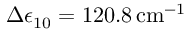Convert formula to latex. <formula><loc_0><loc_0><loc_500><loc_500>\Delta \epsilon _ { 1 0 } = 1 2 0 . 8 \, c m ^ { - 1 }</formula> 